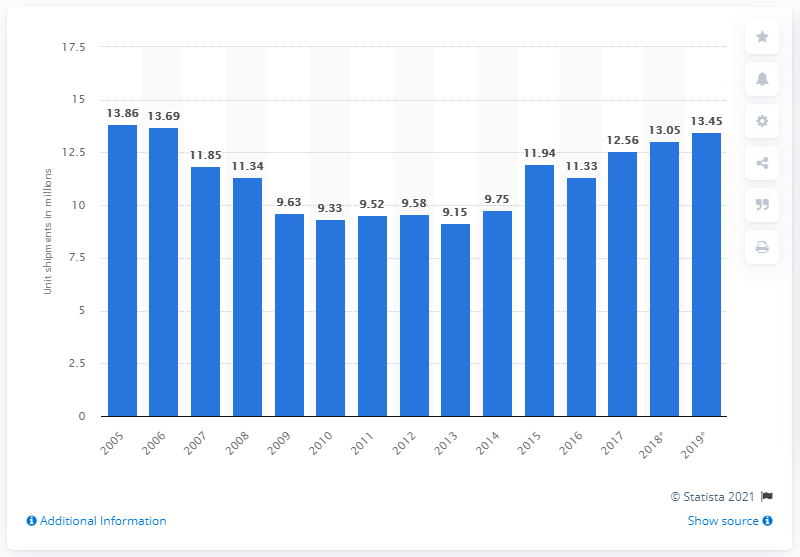Specify some key components in this picture. During the period of 2005 to 2013, an average of 9.15 microwave ovens were shipped per year. In 2019, it is projected that 13,450 microwave ovens will be shipped. 